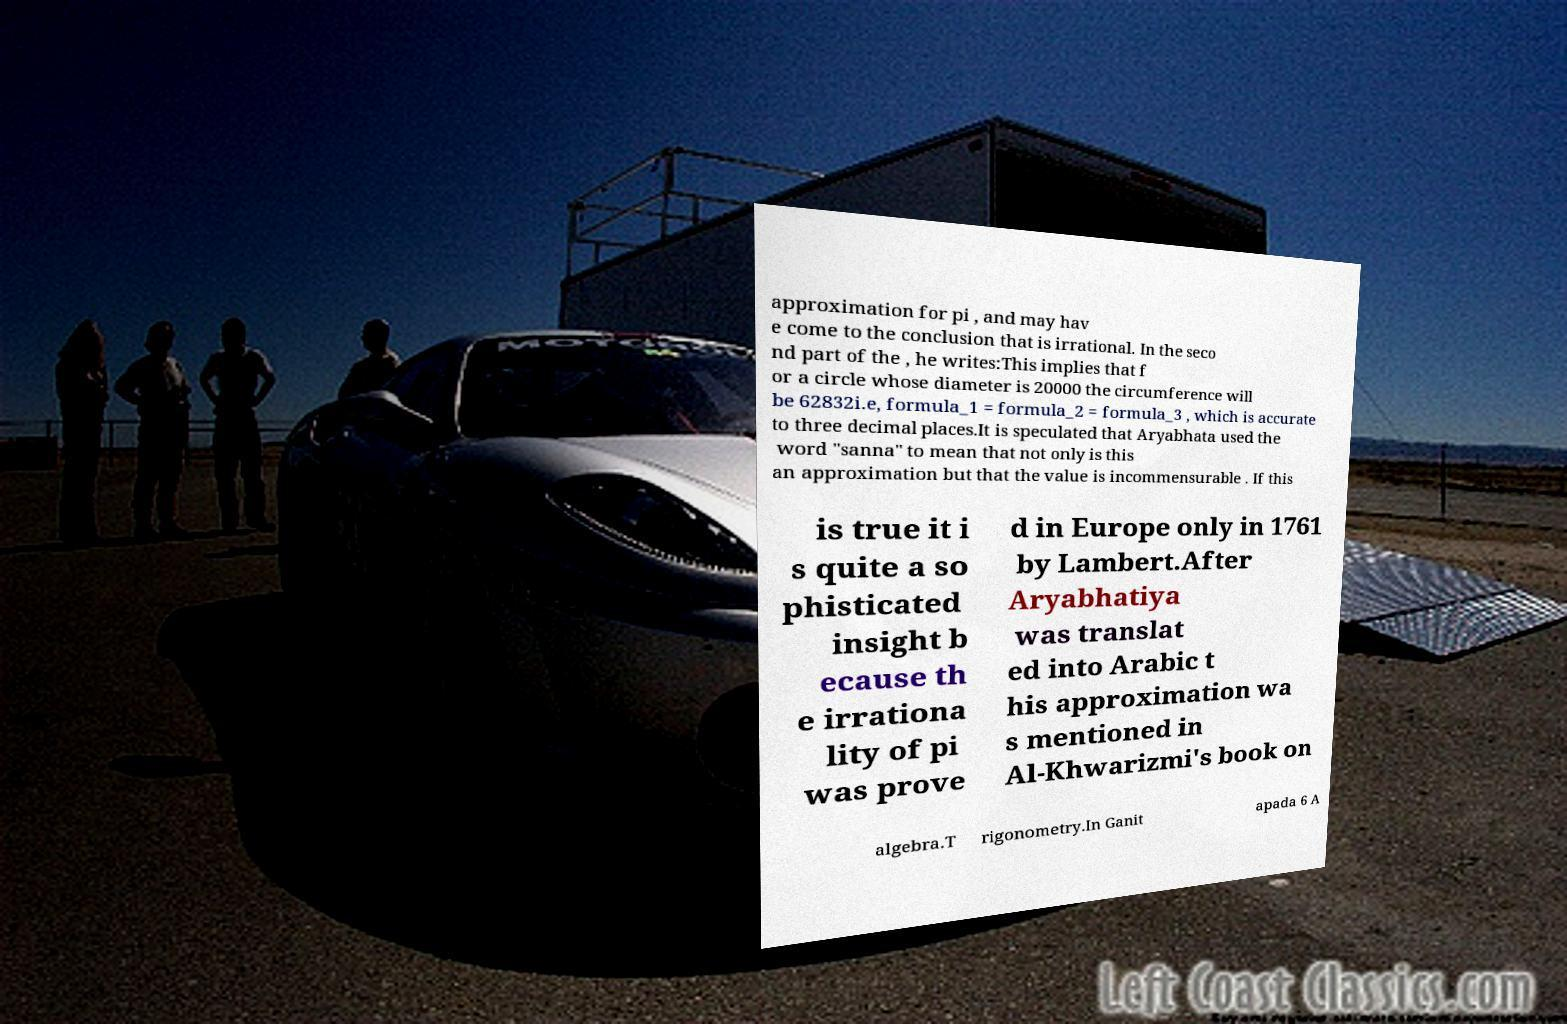What messages or text are displayed in this image? I need them in a readable, typed format. approximation for pi , and may hav e come to the conclusion that is irrational. In the seco nd part of the , he writes:This implies that f or a circle whose diameter is 20000 the circumference will be 62832i.e, formula_1 = formula_2 = formula_3 , which is accurate to three decimal places.It is speculated that Aryabhata used the word "sanna" to mean that not only is this an approximation but that the value is incommensurable . If this is true it i s quite a so phisticated insight b ecause th e irrationa lity of pi was prove d in Europe only in 1761 by Lambert.After Aryabhatiya was translat ed into Arabic t his approximation wa s mentioned in Al-Khwarizmi's book on algebra.T rigonometry.In Ganit apada 6 A 